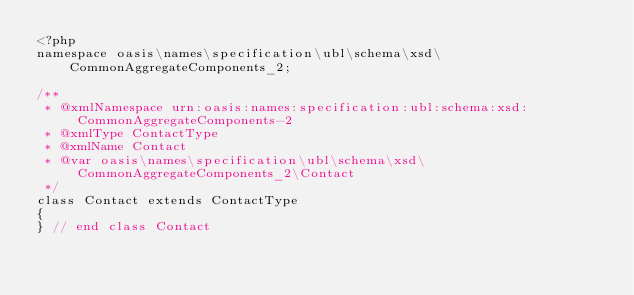<code> <loc_0><loc_0><loc_500><loc_500><_PHP_><?php
namespace oasis\names\specification\ubl\schema\xsd\CommonAggregateComponents_2;

/**
 * @xmlNamespace urn:oasis:names:specification:ubl:schema:xsd:CommonAggregateComponents-2
 * @xmlType ContactType
 * @xmlName Contact
 * @var oasis\names\specification\ubl\schema\xsd\CommonAggregateComponents_2\Contact
 */
class Contact extends ContactType
{
} // end class Contact
</code> 